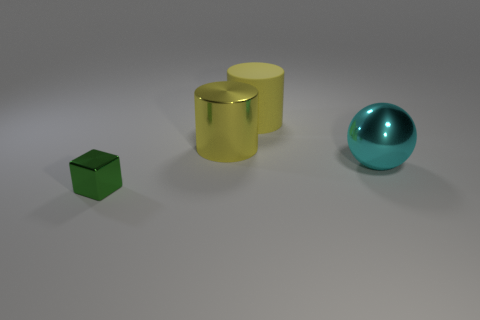Add 2 large yellow shiny cylinders. How many objects exist? 6 Subtract all balls. How many objects are left? 3 Add 2 shiny cubes. How many shiny cubes exist? 3 Subtract 0 yellow spheres. How many objects are left? 4 Subtract all cubes. Subtract all small gray shiny blocks. How many objects are left? 3 Add 4 small green metal cubes. How many small green metal cubes are left? 5 